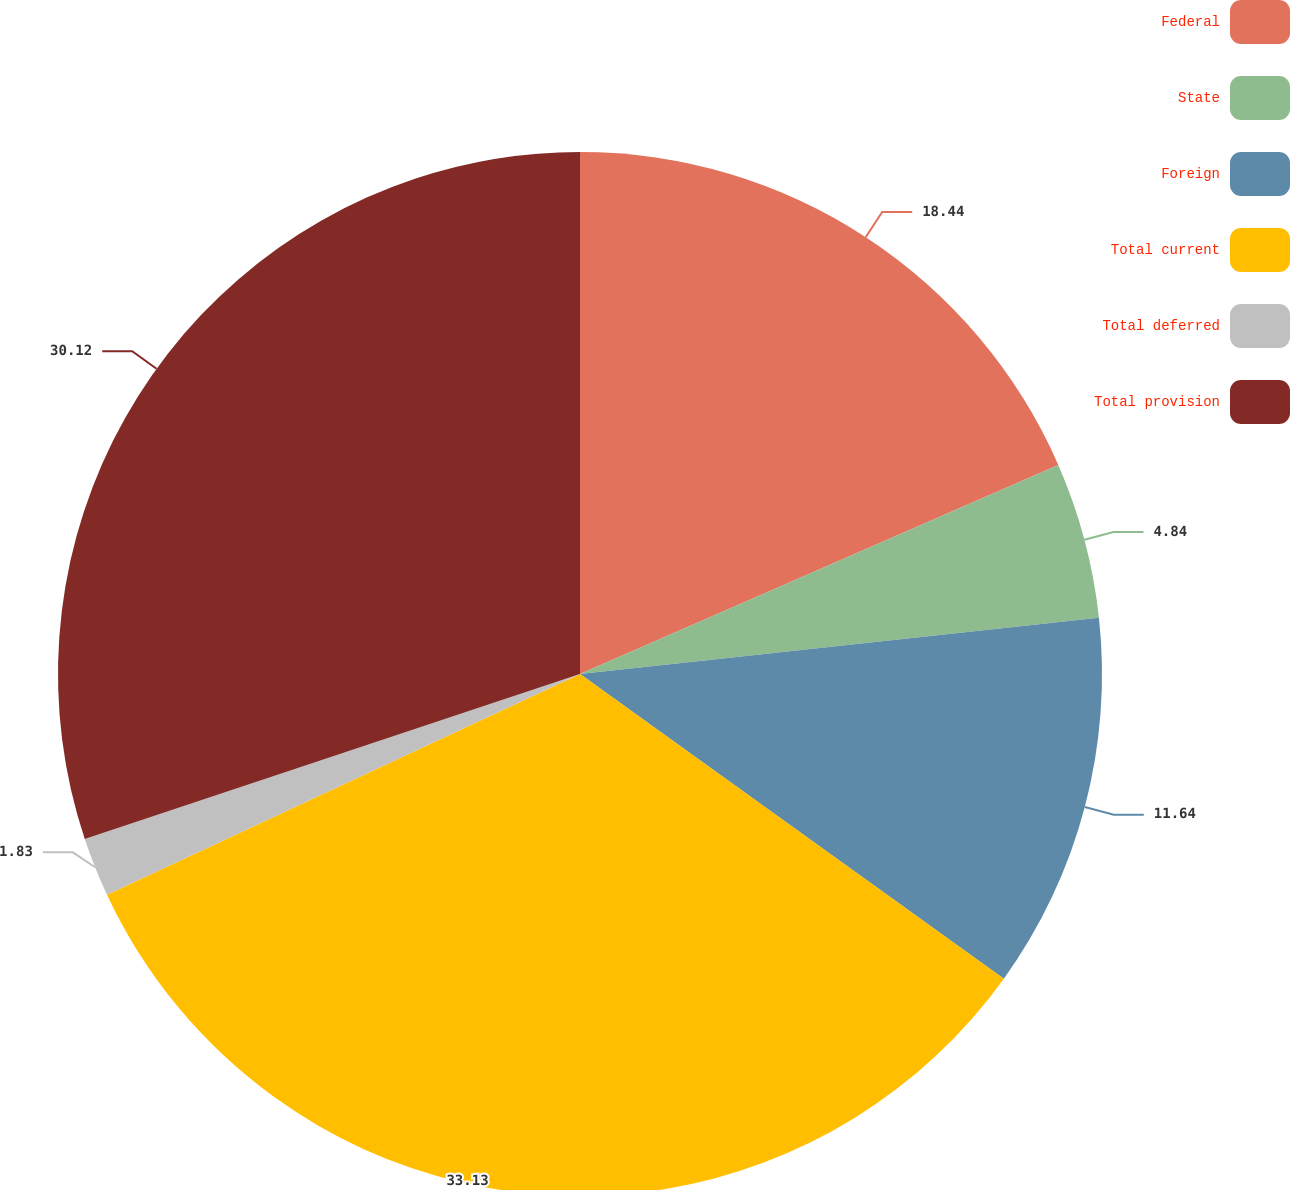Convert chart to OTSL. <chart><loc_0><loc_0><loc_500><loc_500><pie_chart><fcel>Federal<fcel>State<fcel>Foreign<fcel>Total current<fcel>Total deferred<fcel>Total provision<nl><fcel>18.44%<fcel>4.84%<fcel>11.64%<fcel>33.13%<fcel>1.83%<fcel>30.12%<nl></chart> 